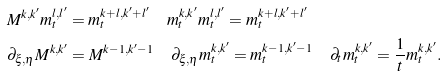Convert formula to latex. <formula><loc_0><loc_0><loc_500><loc_500>& M ^ { k , k ^ { \prime } } m _ { t } ^ { l , l ^ { \prime } } = m _ { t } ^ { k + l , k ^ { \prime } + l ^ { \prime } } \quad m _ { t } ^ { k , k ^ { \prime } } m _ { t } ^ { l , l ^ { \prime } } = m _ { t } ^ { k + l , k ^ { \prime } + l ^ { \prime } } \\ & \partial _ { \xi , \eta } M ^ { k , k ^ { \prime } } = M ^ { k - 1 , k ^ { \prime } - 1 } \quad \partial _ { \xi , \eta } m _ { t } ^ { k , k ^ { \prime } } = m _ { t } ^ { k - 1 , k ^ { \prime } - 1 } \quad \partial _ { t } m _ { t } ^ { k , k ^ { \prime } } = \frac { 1 } { t } m _ { t } ^ { k , k ^ { \prime } } .</formula> 